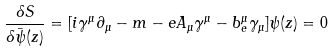Convert formula to latex. <formula><loc_0><loc_0><loc_500><loc_500>\frac { \delta S } { \delta \bar { \psi } ( z ) } = [ i \gamma ^ { \mu } \partial _ { \mu } - m - e A _ { \mu } \gamma ^ { \mu } - b ^ { \mu } _ { e } \gamma _ { \mu } ] \psi ( z ) = 0</formula> 